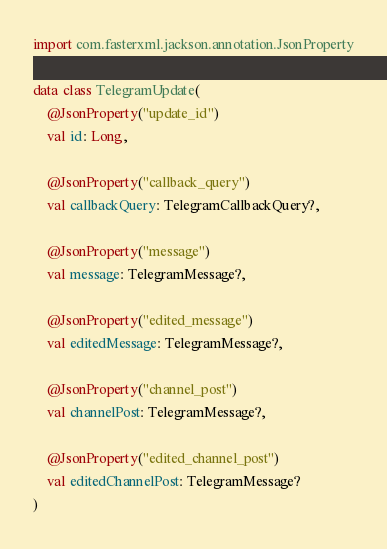Convert code to text. <code><loc_0><loc_0><loc_500><loc_500><_Kotlin_>
import com.fasterxml.jackson.annotation.JsonProperty

data class TelegramUpdate(
    @JsonProperty("update_id")
    val id: Long,

    @JsonProperty("callback_query")
    val callbackQuery: TelegramCallbackQuery?,

    @JsonProperty("message")
    val message: TelegramMessage?,

    @JsonProperty("edited_message")
    val editedMessage: TelegramMessage?,

    @JsonProperty("channel_post")
    val channelPost: TelegramMessage?,

    @JsonProperty("edited_channel_post")
    val editedChannelPost: TelegramMessage?
)</code> 